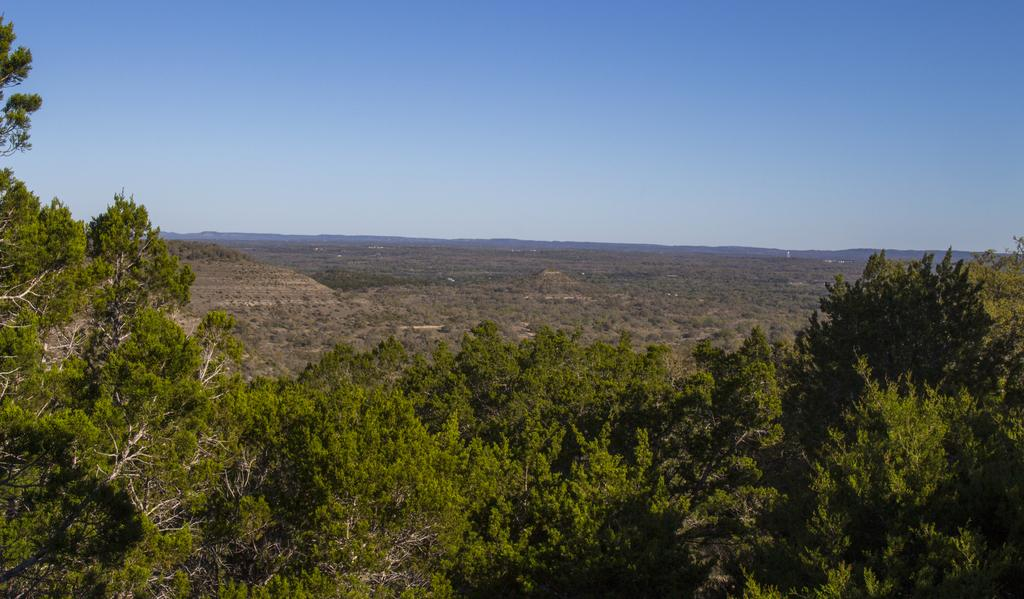What type of vegetation is present in the image? There are trees in the front of the image. What is the surface visible in the image? There is a ground visible in the image. What part of the natural environment is visible in the image? The sky is visible at the top of the image. What type of grape can be seen growing on the trees in the image? There are no grapes visible in the image; only trees are present. What form does the butter take in the image? There is no butter present in the image. 